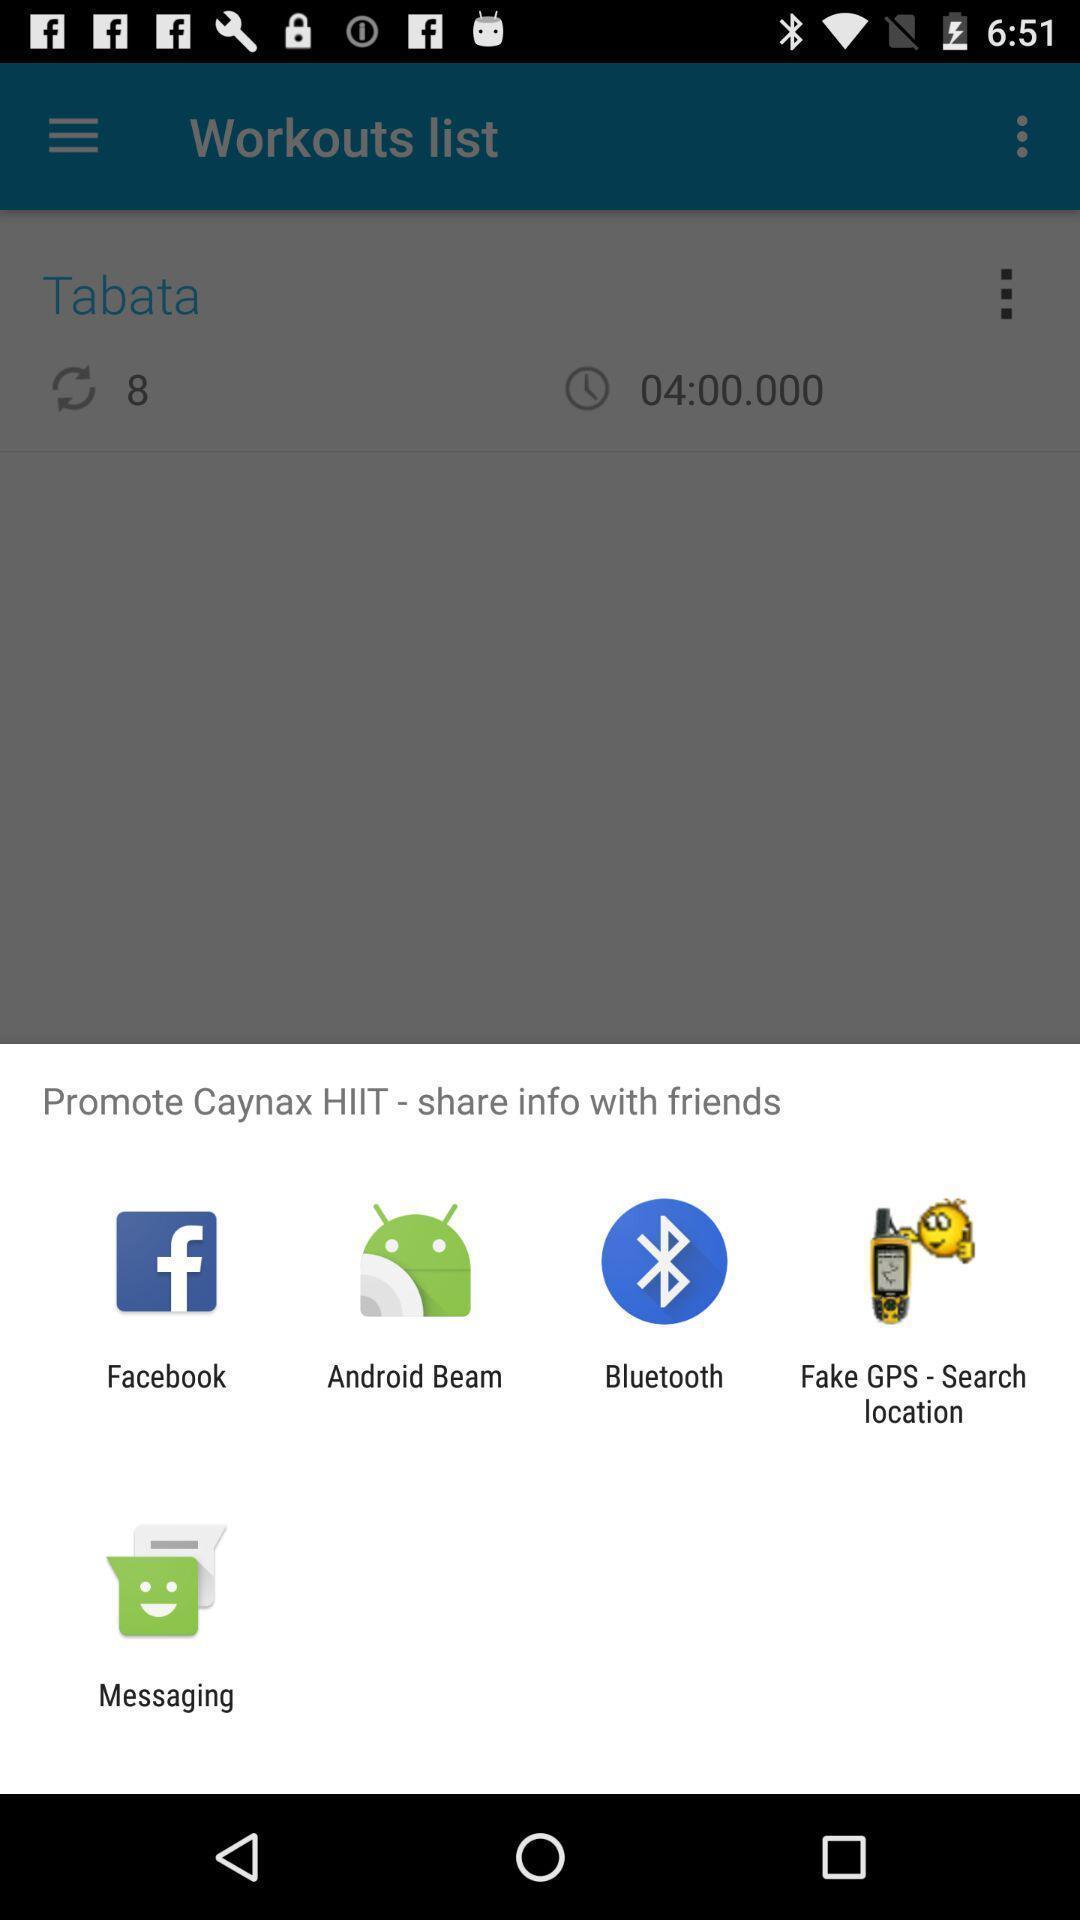What details can you identify in this image? Pop-up shows to share info with friends with multiple apps. 